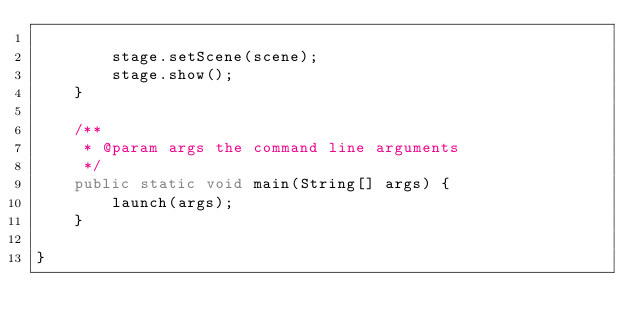Convert code to text. <code><loc_0><loc_0><loc_500><loc_500><_Java_>
        stage.setScene(scene);
        stage.show();
    }

    /**
     * @param args the command line arguments
     */
    public static void main(String[] args) {
        launch(args);
    }

}
</code> 